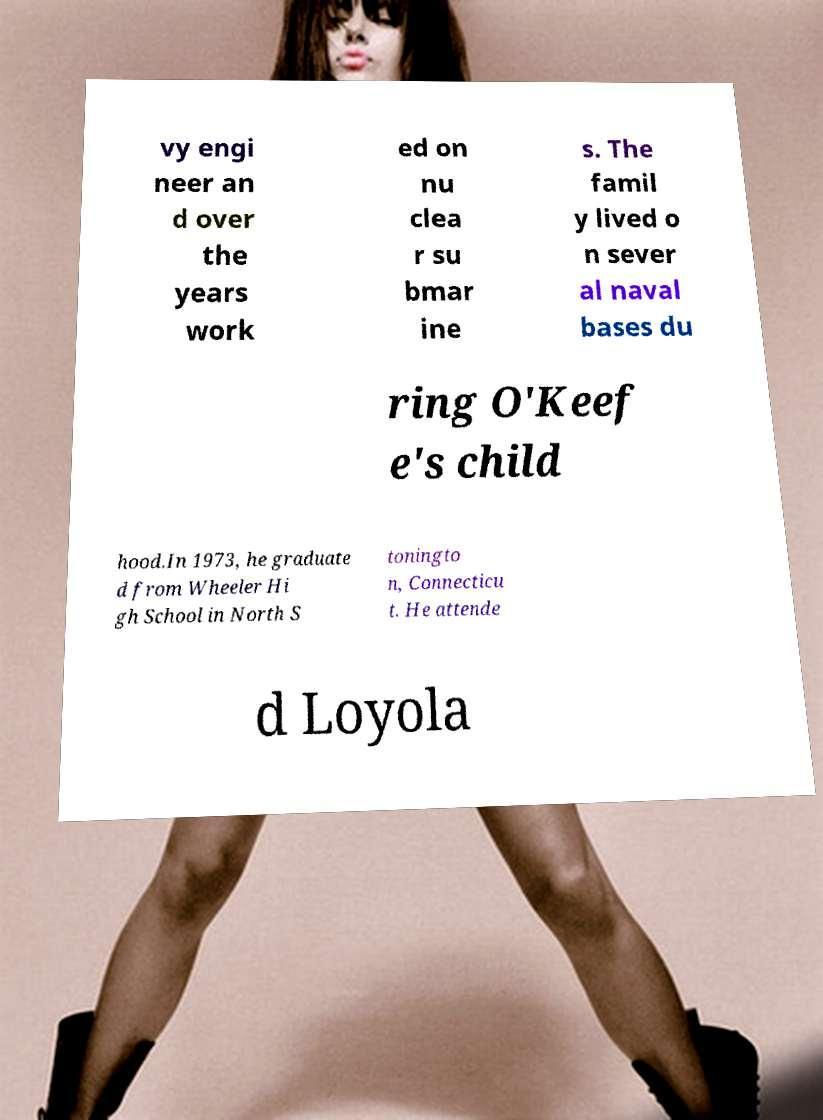For documentation purposes, I need the text within this image transcribed. Could you provide that? vy engi neer an d over the years work ed on nu clea r su bmar ine s. The famil y lived o n sever al naval bases du ring O'Keef e's child hood.In 1973, he graduate d from Wheeler Hi gh School in North S toningto n, Connecticu t. He attende d Loyola 